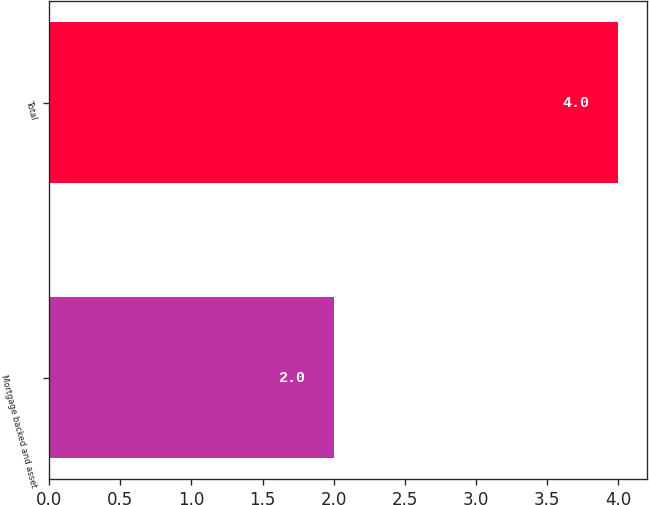Convert chart. <chart><loc_0><loc_0><loc_500><loc_500><bar_chart><fcel>Mortgage backed and asset<fcel>Total<nl><fcel>2<fcel>4<nl></chart> 